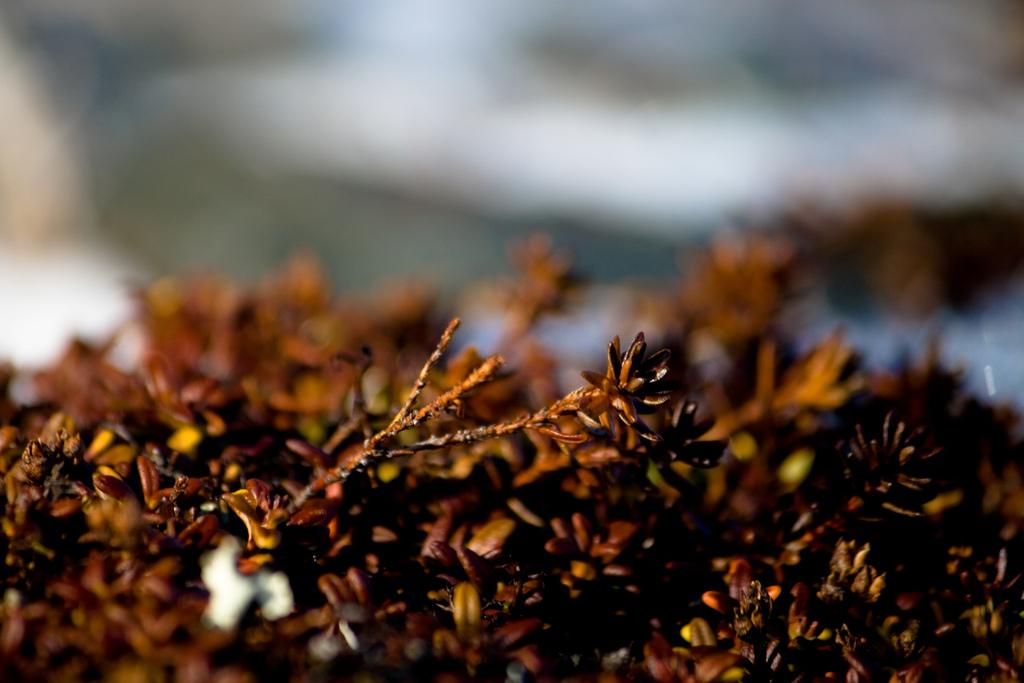What type of flowers are in the image? There are dried flowers in the image. What is the color of the dried flowers? The dried flowers are brown in color. Can you describe the background of the image? The background of the image is blurred. What type of meal is being prepared in the image? There is no meal being prepared in the image; it features dried flowers. Is there a spy visible in the image? There is no spy present in the image. 